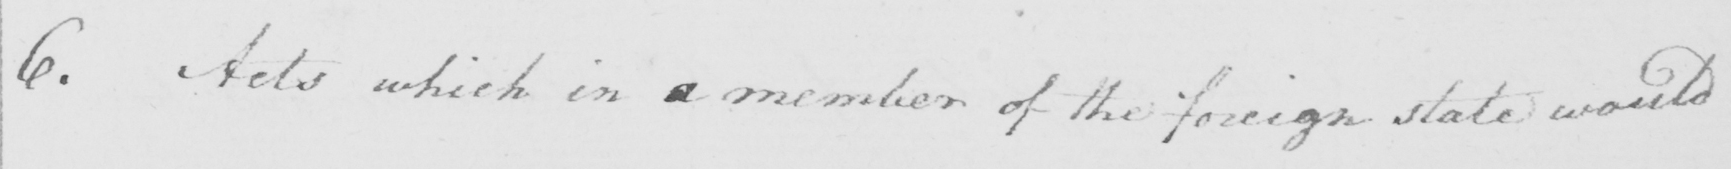What is written in this line of handwriting? 6 . Acts which in a member of the foreign state would 